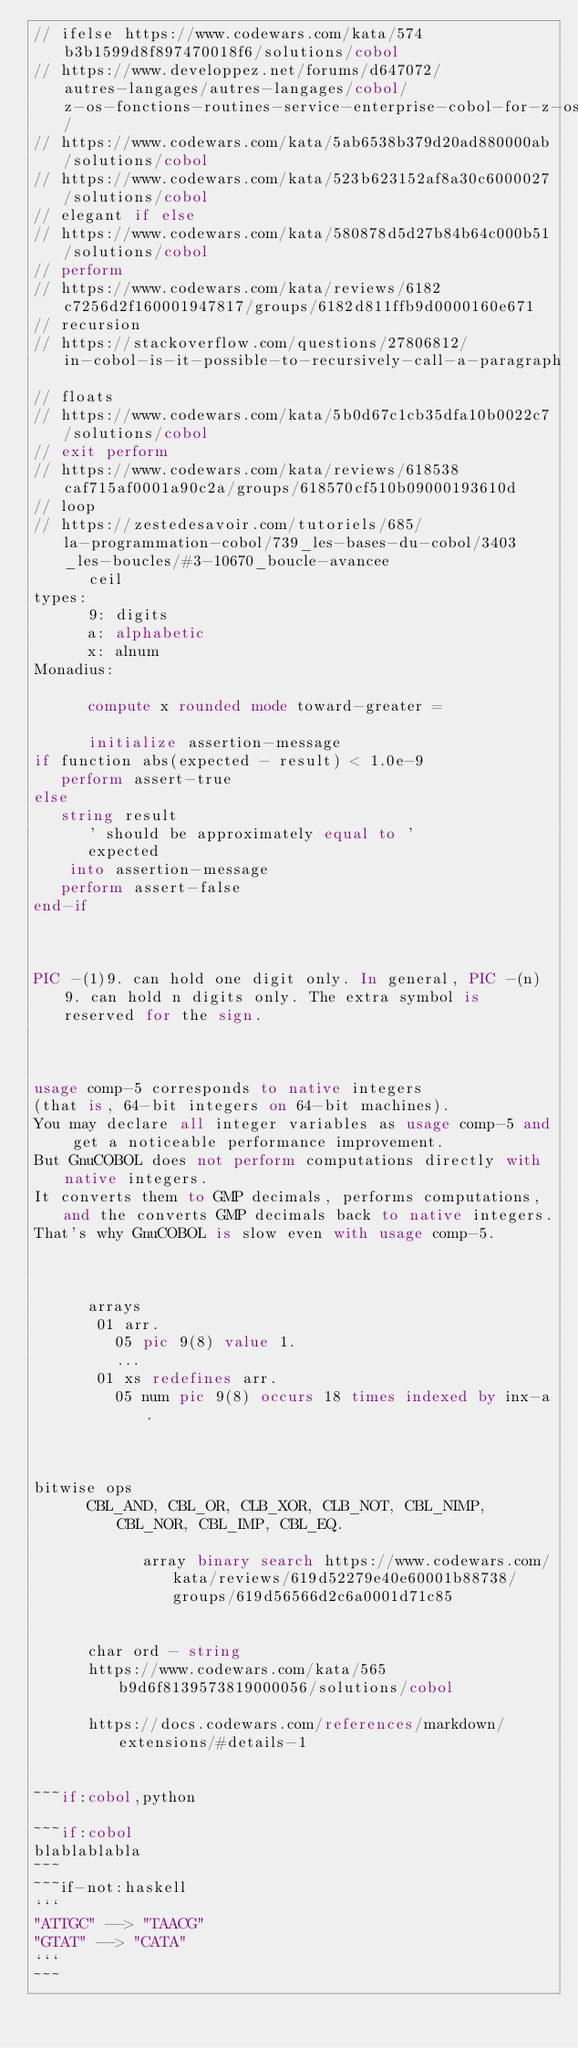<code> <loc_0><loc_0><loc_500><loc_500><_COBOL_>// ifelse https://www.codewars.com/kata/574b3b1599d8f897470018f6/solutions/cobol
// https://www.developpez.net/forums/d647072/autres-langages/autres-langages/cobol/z-os-fonctions-routines-service-enterprise-cobol-for-z-os/
// https://www.codewars.com/kata/5ab6538b379d20ad880000ab/solutions/cobol
// https://www.codewars.com/kata/523b623152af8a30c6000027/solutions/cobol
// elegant if else
// https://www.codewars.com/kata/580878d5d27b84b64c000b51/solutions/cobol
// perform
// https://www.codewars.com/kata/reviews/6182c7256d2f160001947817/groups/6182d811ffb9d0000160e671
// recursion
// https://stackoverflow.com/questions/27806812/in-cobol-is-it-possible-to-recursively-call-a-paragraph
// floats
// https://www.codewars.com/kata/5b0d67c1cb35dfa10b0022c7/solutions/cobol
// exit perform
// https://www.codewars.com/kata/reviews/618538caf715af0001a90c2a/groups/618570cf510b09000193610d
// loop
// https://zestedesavoir.com/tutoriels/685/la-programmation-cobol/739_les-bases-du-cobol/3403_les-boucles/#3-10670_boucle-avancee
      ceil
types:
      9: digits
      a: alphabetic
      x: alnum
Monadius:
      
      compute x rounded mode toward-greater = 

      initialize assertion-message
if function abs(expected - result) < 1.0e-9
   perform assert-true
else
   string result 
      ' should be approximately equal to '
      expected
    into assertion-message
   perform assert-false
end-if

      
      
PIC -(1)9. can hold one digit only. In general, PIC -(n)9. can hold n digits only. The extra symbol is reserved for the sign.
      
      
      
usage comp-5 corresponds to native integers
(that is, 64-bit integers on 64-bit machines).
You may declare all integer variables as usage comp-5 and get a noticeable performance improvement.
But GnuCOBOL does not perform computations directly with native integers.
It converts them to GMP decimals, performs computations, and the converts GMP decimals back to native integers.
That's why GnuCOBOL is slow even with usage comp-5.
      
      
      
      arrays
       01 arr.
         05 pic 9(8) value 1.
         ...
       01 xs redefines arr.
         05 num pic 9(8) occurs 18 times indexed by inx-a.

      
      
bitwise ops
      CBL_AND, CBL_OR, CLB_XOR, CLB_NOT, CBL_NIMP, CBL_NOR, CBL_IMP, CBL_EQ.
      
            array binary search https://www.codewars.com/kata/reviews/619d52279e40e60001b88738/groups/619d56566d2c6a0001d71c85

      
      char ord - string
      https://www.codewars.com/kata/565b9d6f8139573819000056/solutions/cobol
      
      https://docs.codewars.com/references/markdown/extensions/#details-1
      
      
~~~if:cobol,python
      
~~~if:cobol
blablablabla
~~~
~~~if-not:haskell
```
"ATTGC" --> "TAACG"
"GTAT" --> "CATA"
```
~~~
</code> 